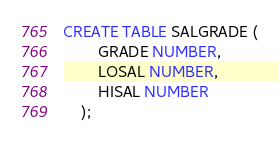<code> <loc_0><loc_0><loc_500><loc_500><_SQL_>CREATE TABLE SALGRADE (
		GRADE NUMBER,
		LOSAL NUMBER,
		HISAL NUMBER
	);</code> 